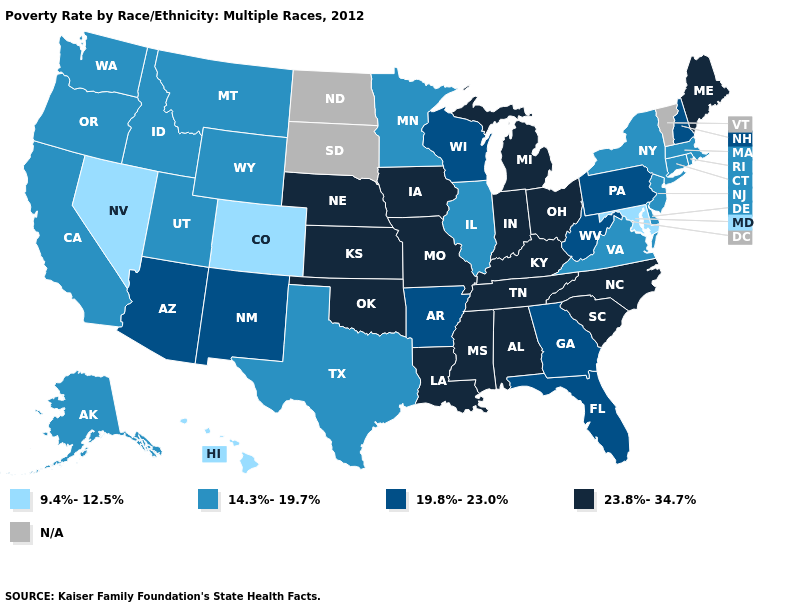Does the map have missing data?
Be succinct. Yes. What is the value of Maine?
Write a very short answer. 23.8%-34.7%. What is the value of South Carolina?
Short answer required. 23.8%-34.7%. What is the highest value in the West ?
Quick response, please. 19.8%-23.0%. Name the states that have a value in the range N/A?
Concise answer only. North Dakota, South Dakota, Vermont. Does Oklahoma have the highest value in the South?
Answer briefly. Yes. Name the states that have a value in the range N/A?
Be succinct. North Dakota, South Dakota, Vermont. Is the legend a continuous bar?
Write a very short answer. No. What is the value of Kentucky?
Concise answer only. 23.8%-34.7%. What is the value of Louisiana?
Quick response, please. 23.8%-34.7%. Name the states that have a value in the range 23.8%-34.7%?
Concise answer only. Alabama, Indiana, Iowa, Kansas, Kentucky, Louisiana, Maine, Michigan, Mississippi, Missouri, Nebraska, North Carolina, Ohio, Oklahoma, South Carolina, Tennessee. Does Nevada have the lowest value in the USA?
Quick response, please. Yes. Among the states that border Ohio , which have the lowest value?
Answer briefly. Pennsylvania, West Virginia. 